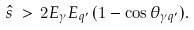Convert formula to latex. <formula><loc_0><loc_0><loc_500><loc_500>\hat { s } \, > \, 2 E _ { \gamma } E _ { q ^ { \prime } } \, ( 1 - \cos \theta _ { \gamma q ^ { \prime } } ) .</formula> 